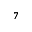Convert formula to latex. <formula><loc_0><loc_0><loc_500><loc_500>^ { 7 }</formula> 